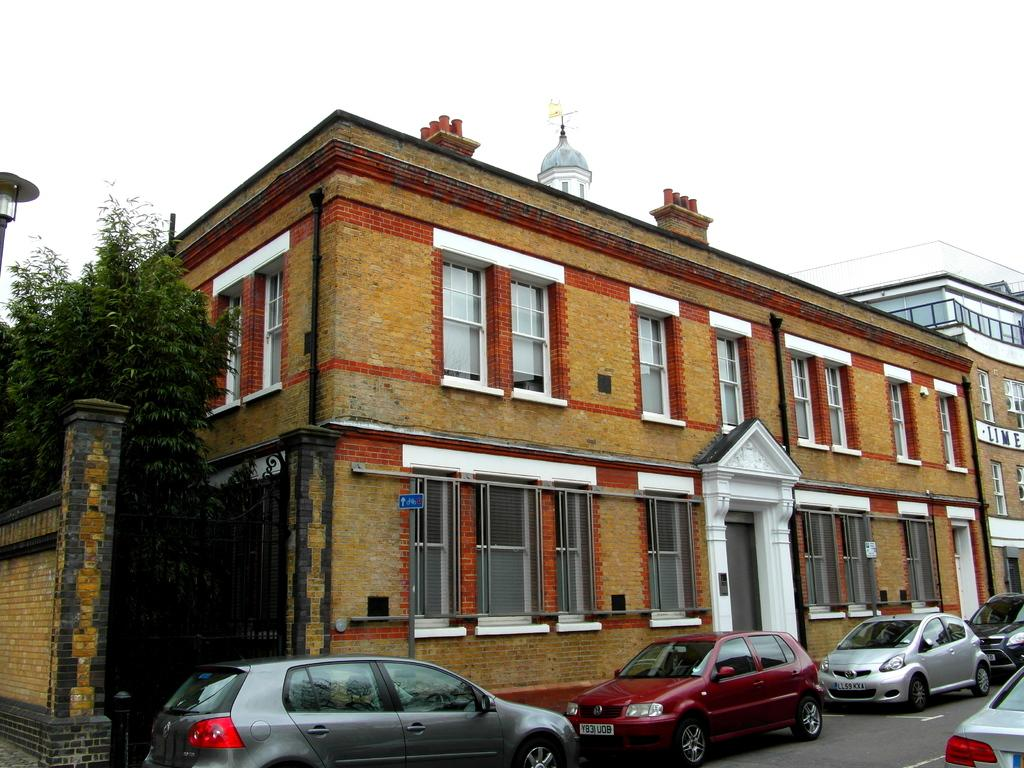Where was the image taken? The image was taken on a road. What can be seen on the road in the image? There are cars parked on the road in the image. What is visible behind the parked cars? There are buildings behind the parked cars in the image. What is visible at the top of the image? The sky is visible at the top of the image. What type of vegetation is on the left side of the image? There are trees to the left of the image. Can you see any ants crawling on the parked cars in the image? There are no ants visible on the parked cars in the image. Are there any icicles hanging from the trees in the image? There are no icicles present in the image, as it is taken on a road with trees and no indication of freezing temperatures. 